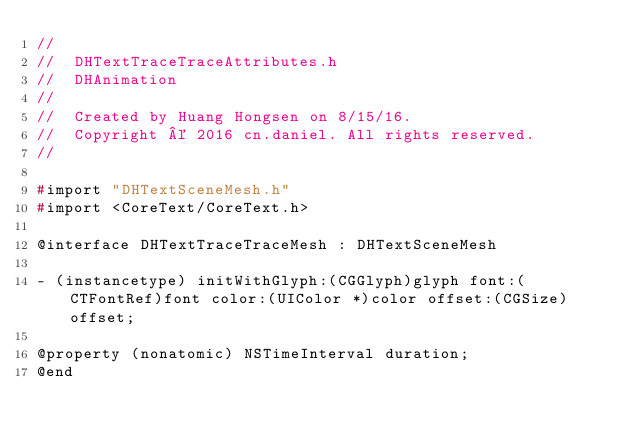<code> <loc_0><loc_0><loc_500><loc_500><_C_>//
//  DHTextTraceTraceAttributes.h
//  DHAnimation
//
//  Created by Huang Hongsen on 8/15/16.
//  Copyright © 2016 cn.daniel. All rights reserved.
//

#import "DHTextSceneMesh.h"
#import <CoreText/CoreText.h>

@interface DHTextTraceTraceMesh : DHTextSceneMesh

- (instancetype) initWithGlyph:(CGGlyph)glyph font:(CTFontRef)font color:(UIColor *)color offset:(CGSize)offset;

@property (nonatomic) NSTimeInterval duration;
@end
</code> 